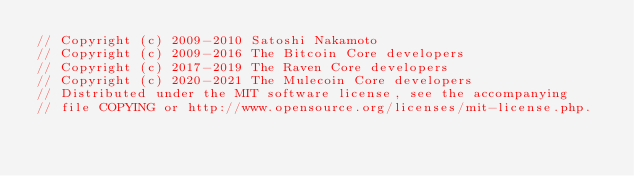<code> <loc_0><loc_0><loc_500><loc_500><_C_>// Copyright (c) 2009-2010 Satoshi Nakamoto
// Copyright (c) 2009-2016 The Bitcoin Core developers
// Copyright (c) 2017-2019 The Raven Core developers
// Copyright (c) 2020-2021 The Mulecoin Core developers
// Distributed under the MIT software license, see the accompanying
// file COPYING or http://www.opensource.org/licenses/mit-license.php.
</code> 